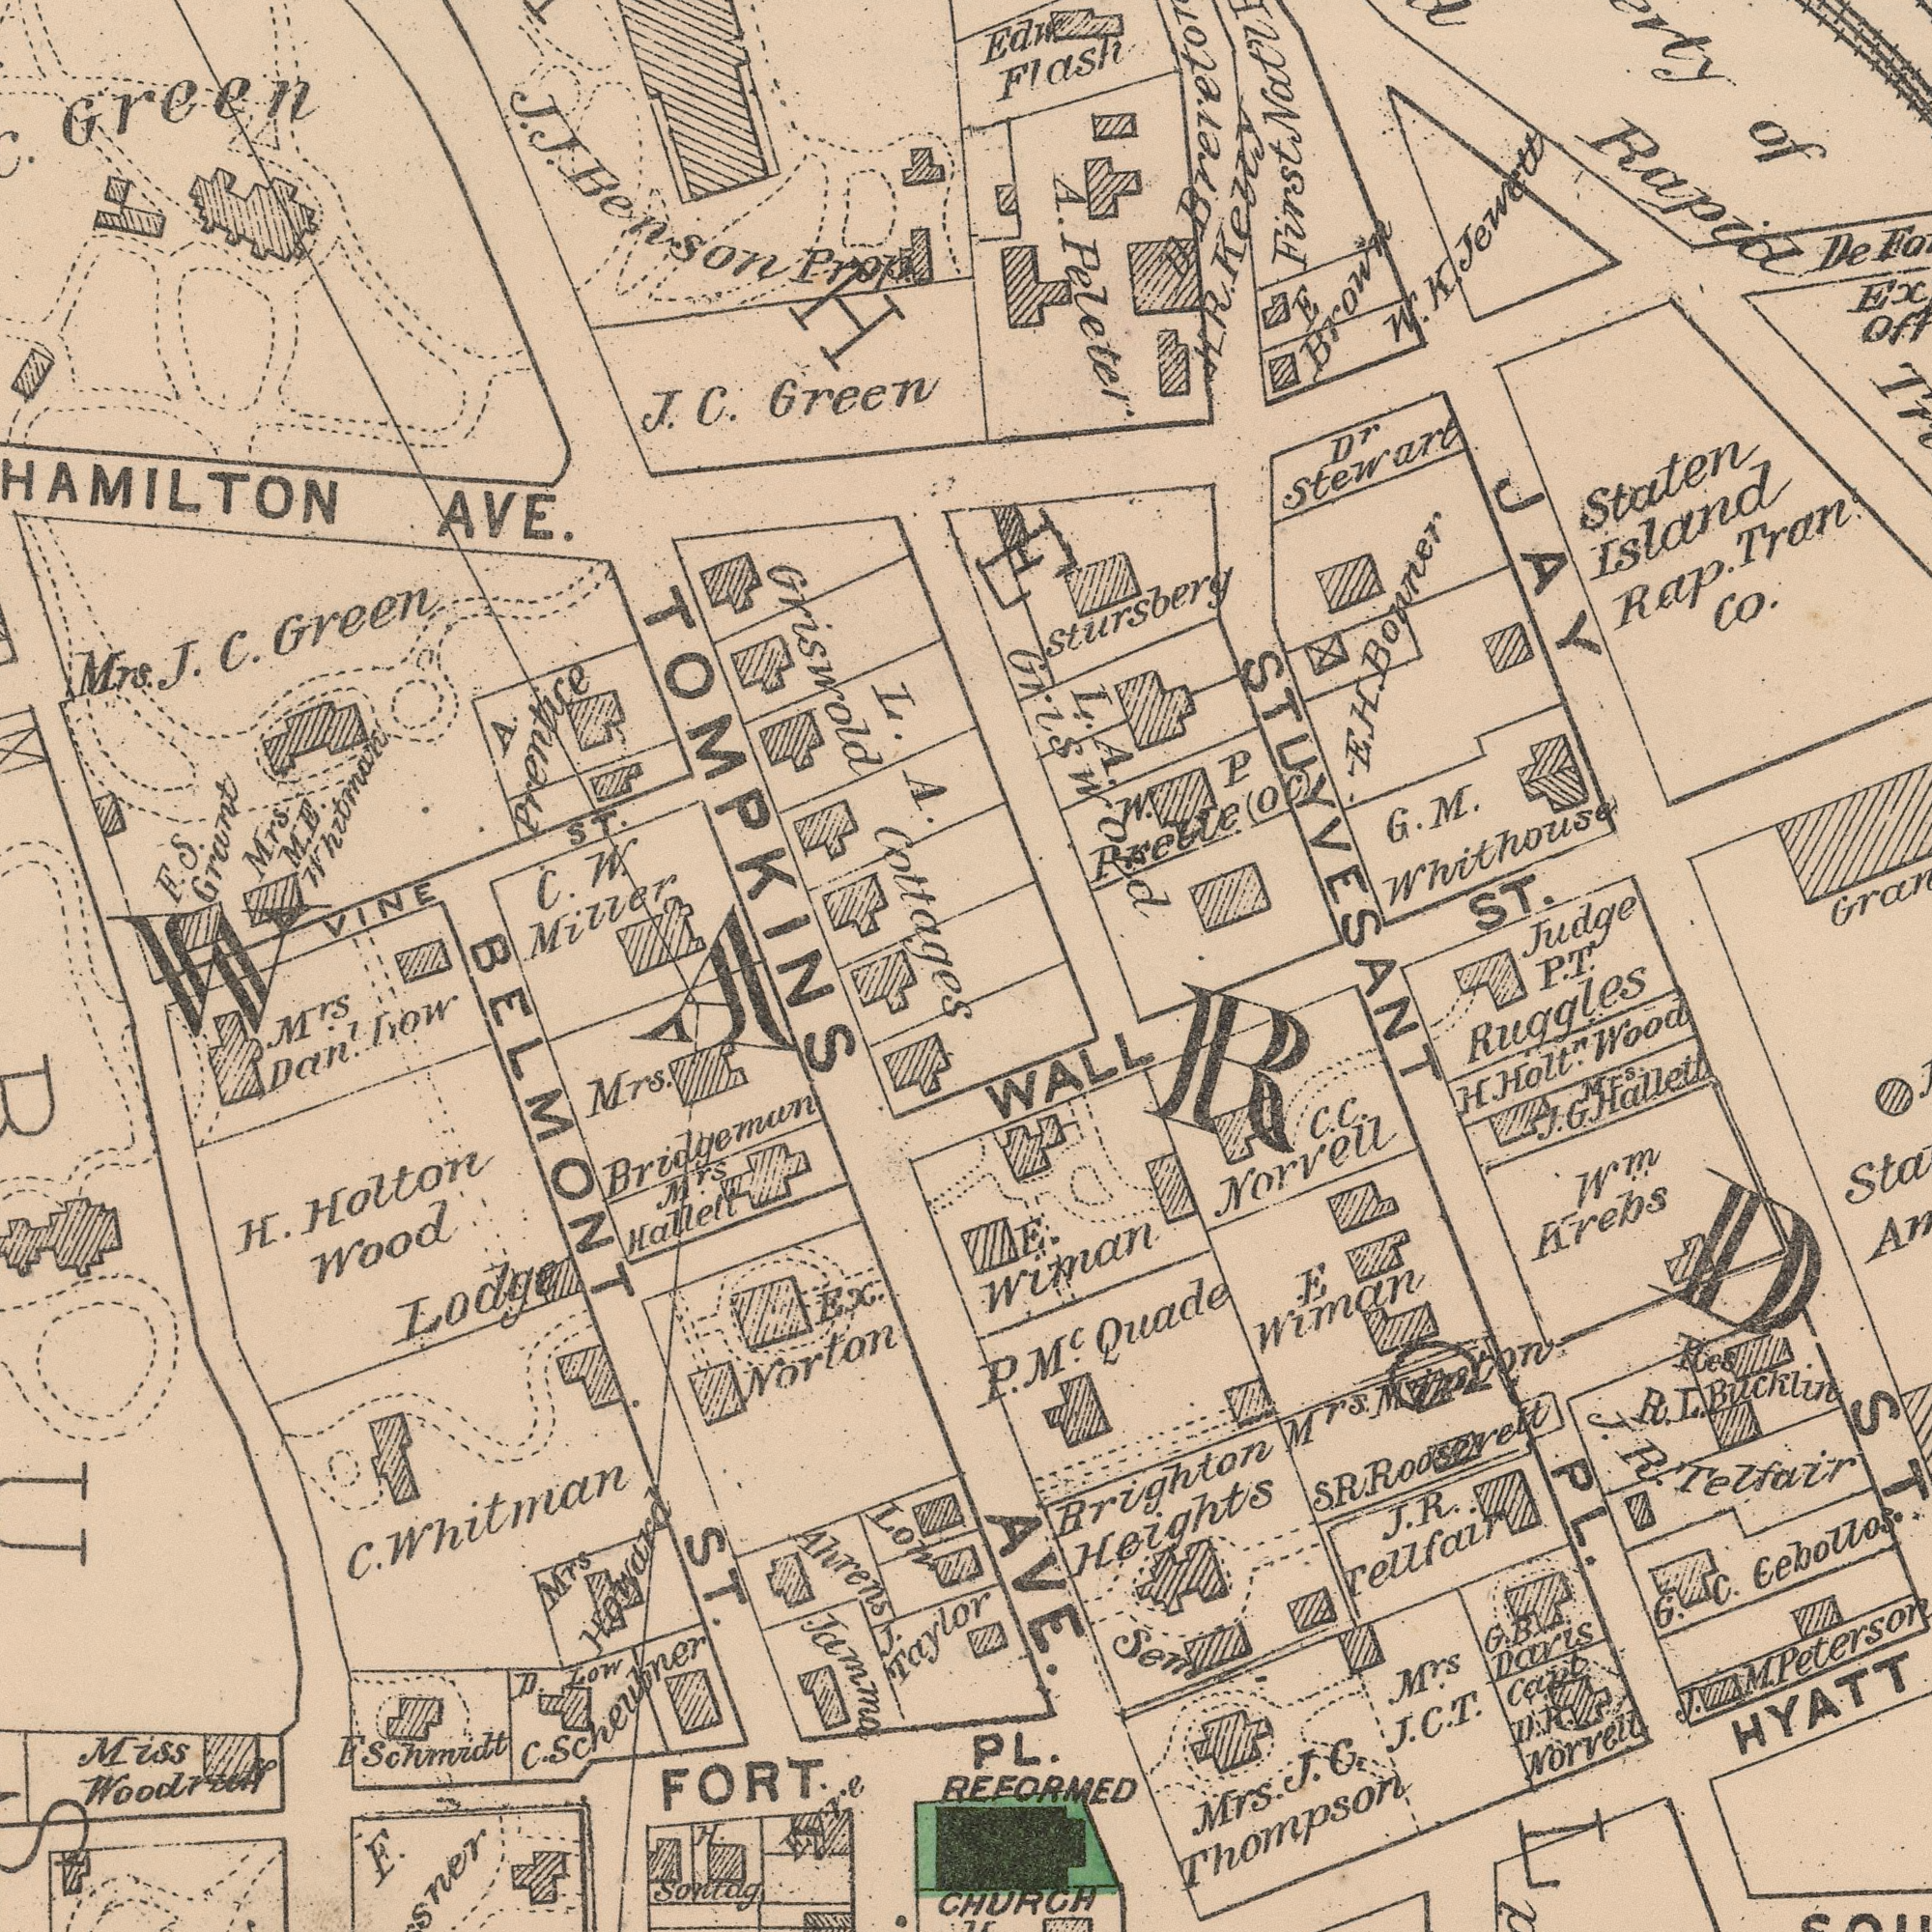What text appears in the top-right area of the image? Staten Island Rap. Tran Co. A. Peleter Edw Flash Rapid Judge T. L. A. Griswold E. H. Bonner G. M. Whithouse W. P Rkelle(oc) ST. W. K. Jewett Dr Stewart Stursbery De E Brown of First Nat’l JAY D. H. R. Kezzy STUYVESANT What text appears in the bottom-left area of the image? H. Holton Wood Miss Woodruff Lodge D. Zow M.rs Hallelt M.rs Dan now H. Sontag Low Ahrens Ex. Norton E. Jamma C. Scheubner F. Schmidt Mrs Howard Mrs. Bridgeman BELMONT ST. C. Whitman FORT Eyre J. Taylor WARD What text appears in the bottom-right area of the image? AVE. P. Ruggles WALL ST. PL. REFORMED HURCH P. M.c Quade E Wiman C. C. Norvell H. Holt. Wood Wm. Krebs E. Wiman J. R. Tellfair G. B. Daris Caub G. C. Cebollos D. R. Norvell M.rs J. C. T. Brighton Heights Res R. L. Bucklin Mrs. J. G. Thompson HYATT J. M. Peterson Sem PL. Mrs.. J. G. Hallett Mrs. Mipton J. R. Telfair S. R. Roosevett What text can you see in the top-left section? L. A. Griswold Cottages AVE. Mrs. J. C. Green J. C. Green Mrs. M. E. Whitman F. S. Grant C. Green J. J. Benson Prop VINE ST. A Prentice C. W. Miller TOMPKINS 